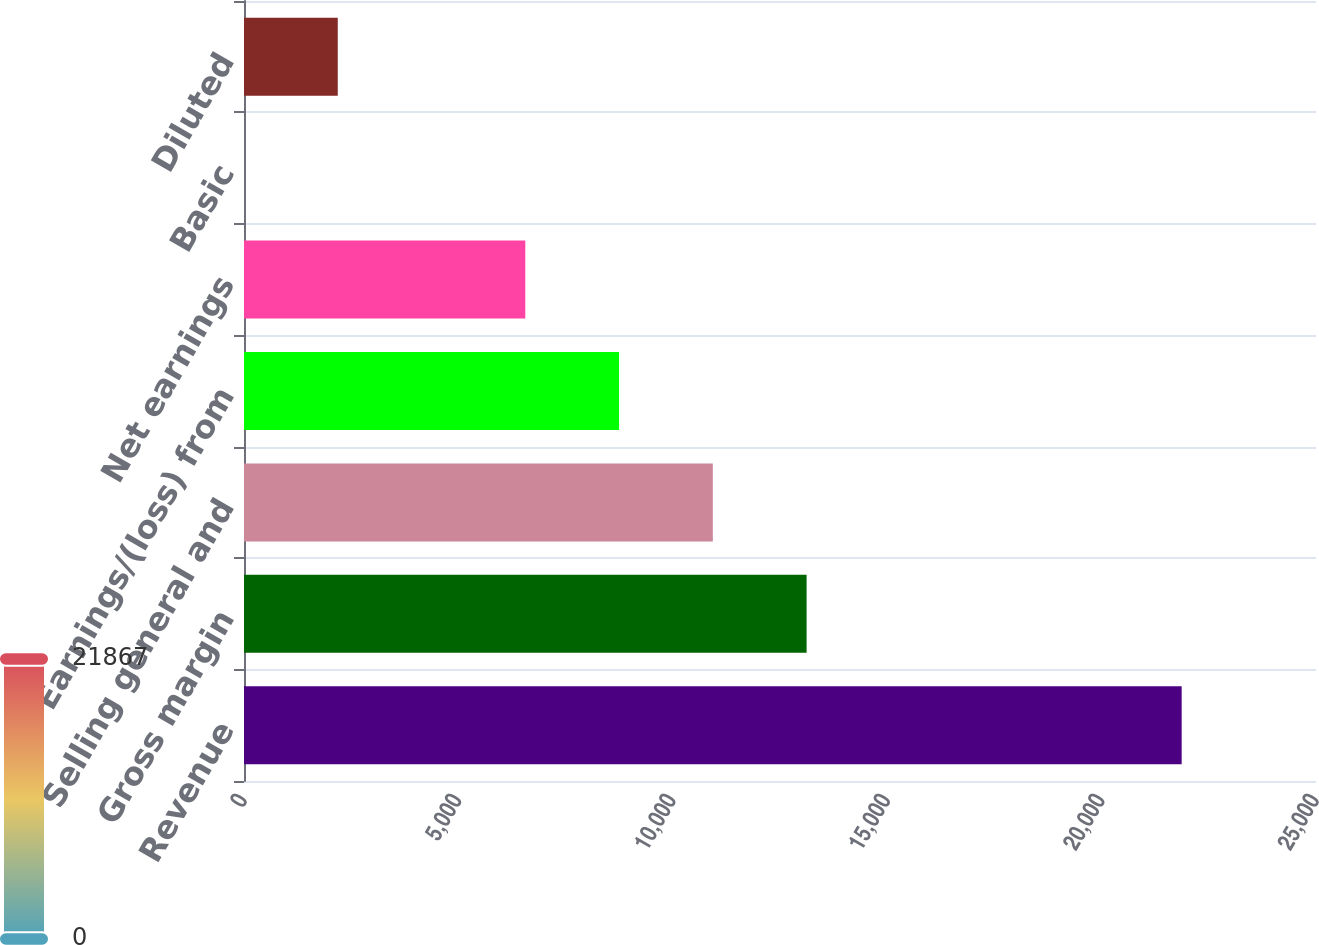Convert chart to OTSL. <chart><loc_0><loc_0><loc_500><loc_500><bar_chart><fcel>Revenue<fcel>Gross margin<fcel>Selling general and<fcel>Earnings/(loss) from<fcel>Net earnings<fcel>Basic<fcel>Diluted<nl><fcel>21867.1<fcel>13120.3<fcel>10933.6<fcel>8746.85<fcel>6560.14<fcel>0.01<fcel>2186.72<nl></chart> 